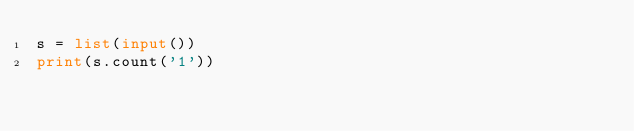Convert code to text. <code><loc_0><loc_0><loc_500><loc_500><_Python_>s = list(input())
print(s.count('1'))
</code> 